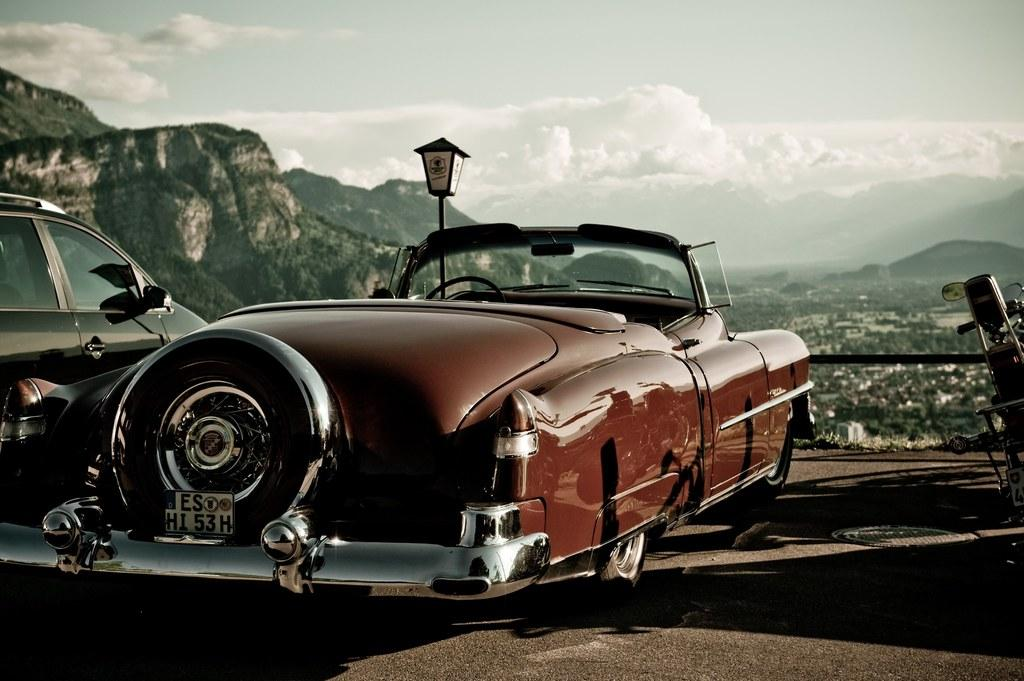What types of vehicles are in the image? There are cars in the image. What other mode of transportation can be seen in the image? There is a bike in the image. What object is present in the image that is not a vehicle or mode of transportation? There is a pole in the image. What is the source of illumination in the image? There is a light in the image. What natural feature is visible in the background of the image? There is a mountain in the background of the image. What else can be seen in the sky in the background of the image? There are clouds in the sky. Can you tell me how many basketballs are on the mountain in the image? There are no basketballs present in the image, and therefore no such objects can be found on the mountain. 